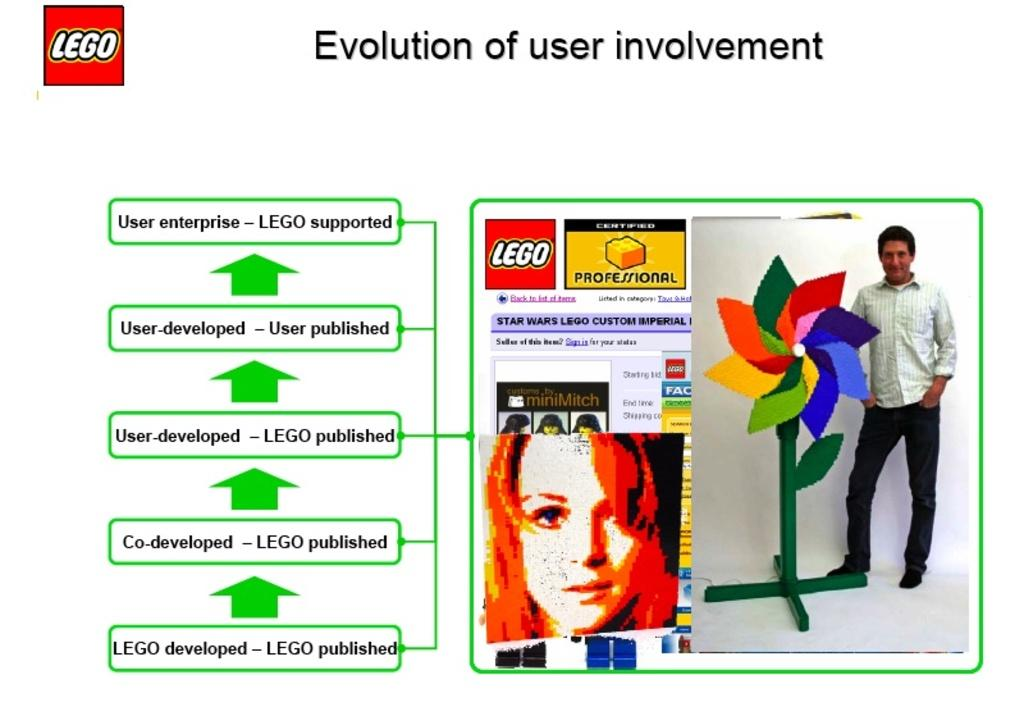What is present on the poster in the image? The poster contains images, text, and logos. Can you describe the images on the poster? The provided facts do not specify the content of the images on the poster. What type of information is conveyed through the text on the poster? The provided facts do not specify the content of the text on the poster. What type of logos are included on the poster? The provided facts do not specify the content of the logos on the poster. What type of grass is growing in the drawer in the image? There is no drawer or grass present in the image. What type of front is visible in the image? The provided facts do not specify any fronts in the image. 